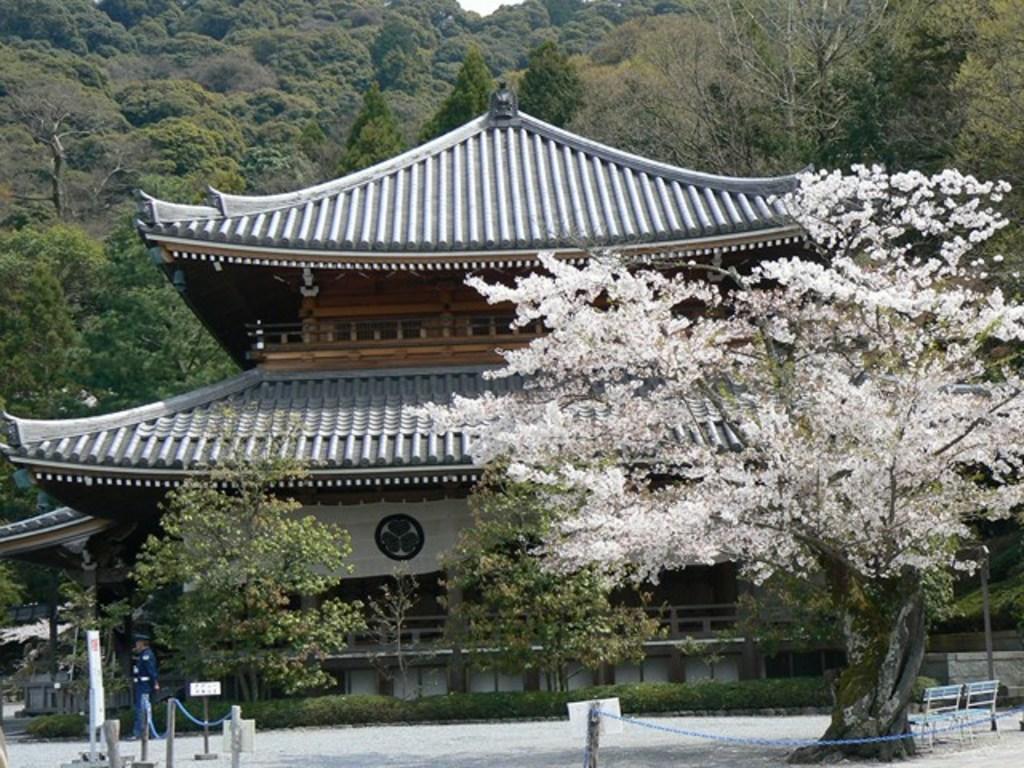In one or two sentences, can you explain what this image depicts? In this image, we can see some trees and plants. There is a hill at the top of the image. There is a barricade stand in the bottom left and in the bottom right of the image. There is a person walking on the road. There are benches in front of the chinese temple. 